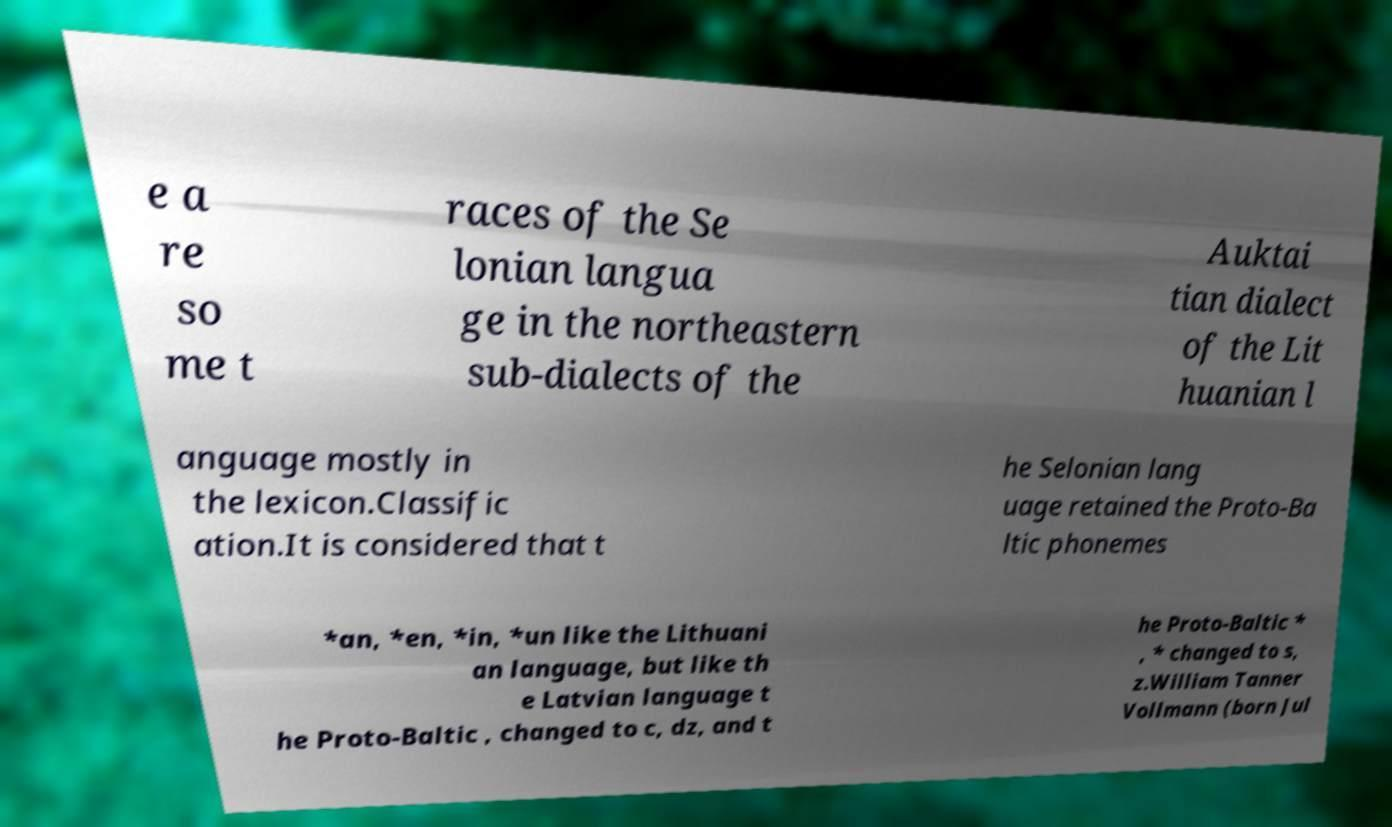There's text embedded in this image that I need extracted. Can you transcribe it verbatim? e a re so me t races of the Se lonian langua ge in the northeastern sub-dialects of the Auktai tian dialect of the Lit huanian l anguage mostly in the lexicon.Classific ation.It is considered that t he Selonian lang uage retained the Proto-Ba ltic phonemes *an, *en, *in, *un like the Lithuani an language, but like th e Latvian language t he Proto-Baltic , changed to c, dz, and t he Proto-Baltic * , * changed to s, z.William Tanner Vollmann (born Jul 